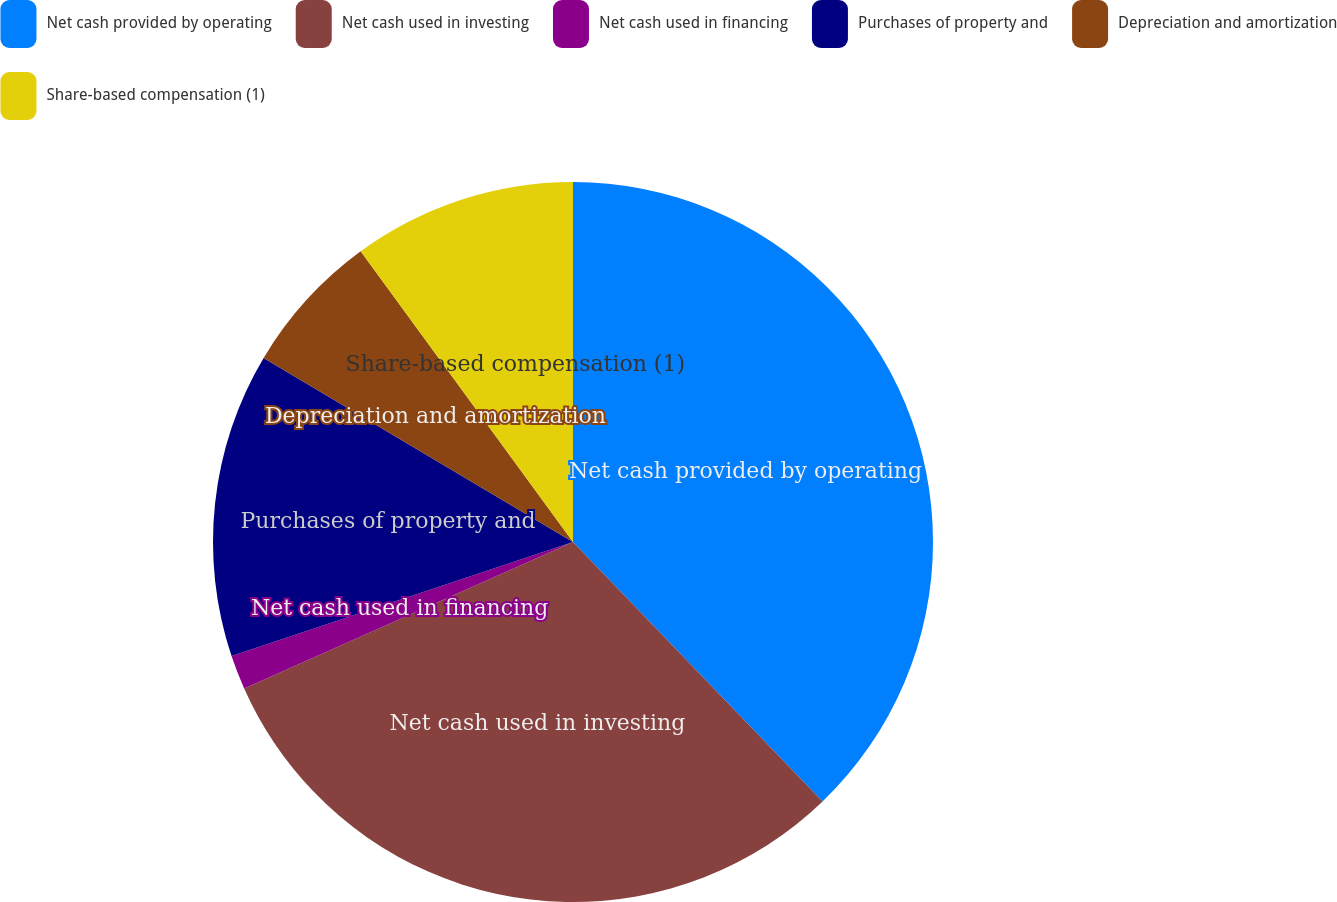Convert chart to OTSL. <chart><loc_0><loc_0><loc_500><loc_500><pie_chart><fcel>Net cash provided by operating<fcel>Net cash used in investing<fcel>Net cash used in financing<fcel>Purchases of property and<fcel>Depreciation and amortization<fcel>Share-based compensation (1)<nl><fcel>37.81%<fcel>30.52%<fcel>1.54%<fcel>13.67%<fcel>6.42%<fcel>10.04%<nl></chart> 